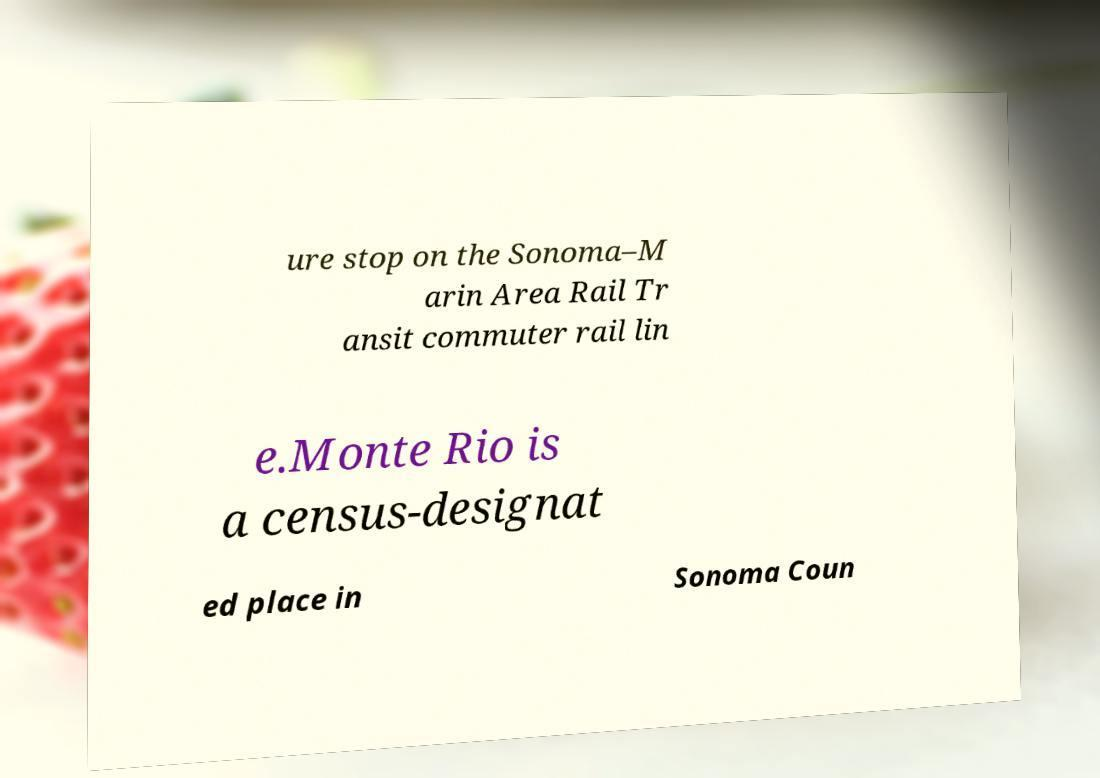There's text embedded in this image that I need extracted. Can you transcribe it verbatim? ure stop on the Sonoma–M arin Area Rail Tr ansit commuter rail lin e.Monte Rio is a census-designat ed place in Sonoma Coun 